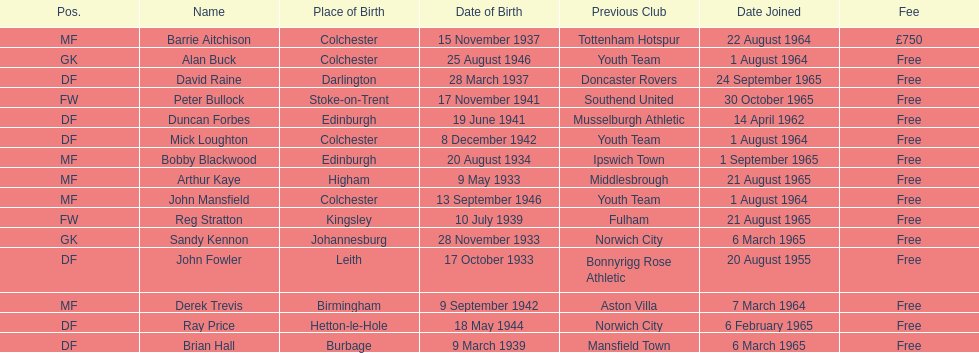Which team was ray price on before he started for this team? Norwich City. 